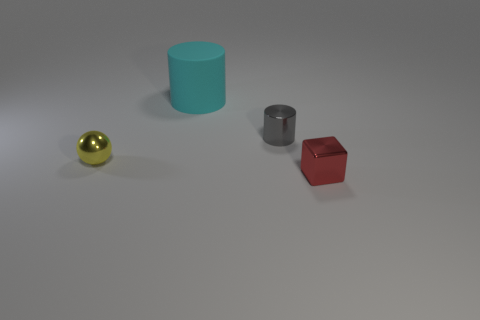What number of objects are brown cylinders or blocks? There are no objects that are brown cylinders or blocks. The objects consist of a blue cylinder, a metallic cylinder, a red block, and a golden sphere. 